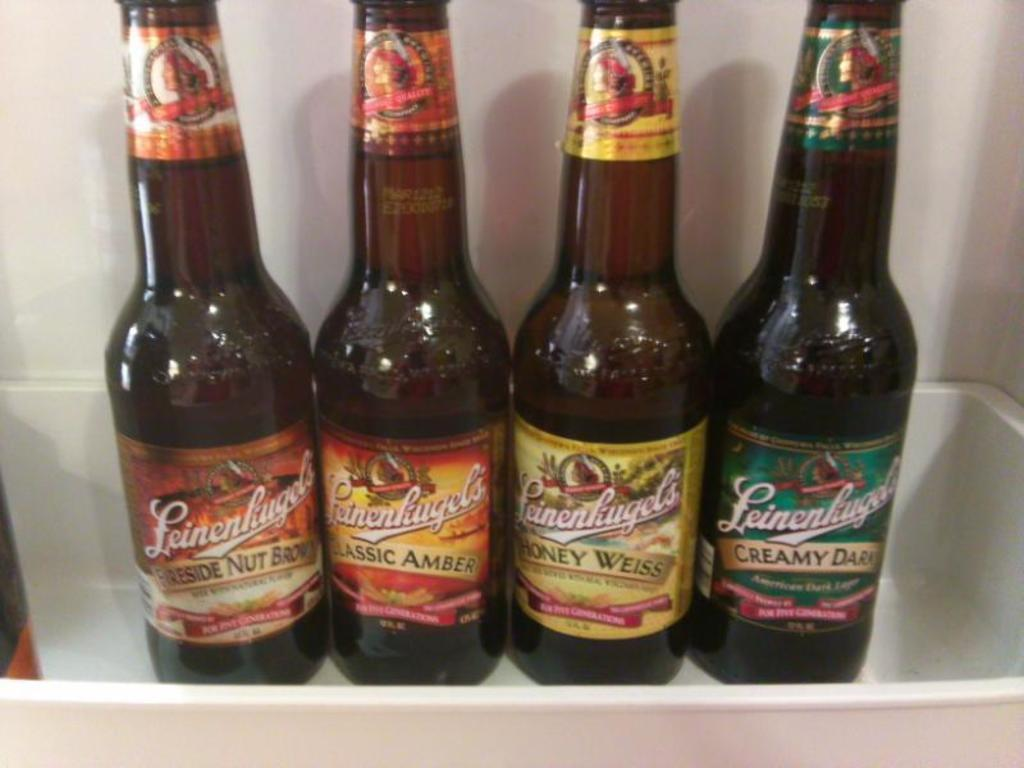<image>
Create a compact narrative representing the image presented. the word creamy is on one of the beer bottles 